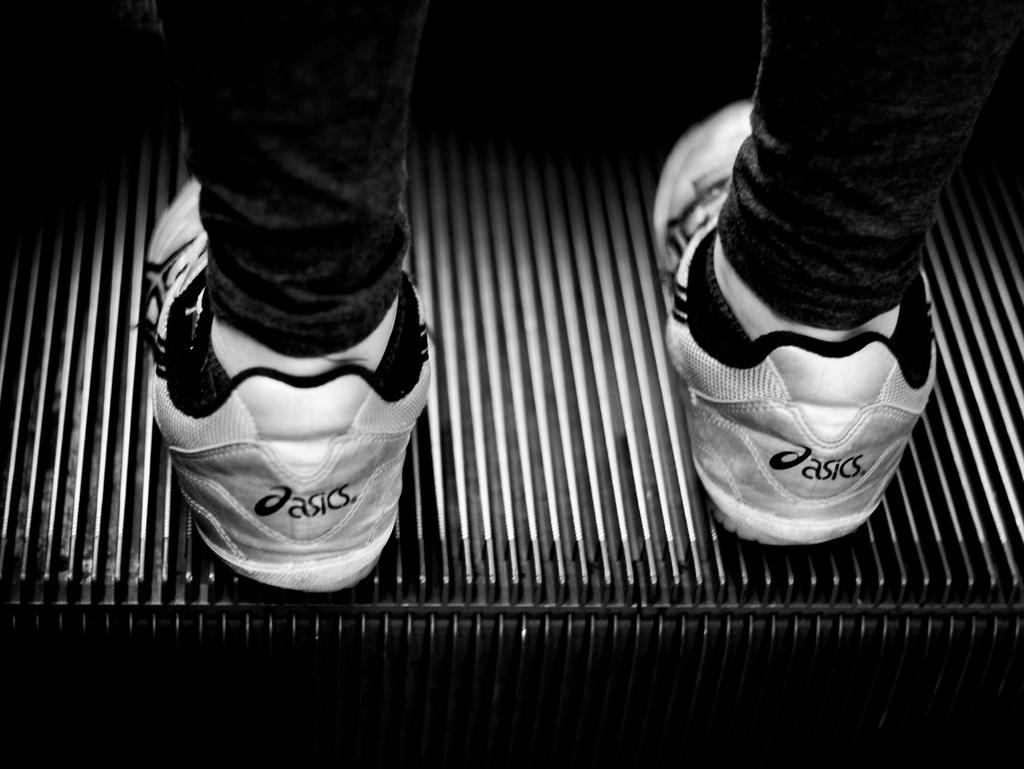What is the main subject in the foreground of the image? There is a person in the foreground of the image. What is the person doing in the image? The person is standing in the image. What type of footwear is the person wearing? The person is wearing shoes. Where is the person standing in the image? The person is standing on an escalator. What type of engine can be seen in the image? There is no engine present in the image. How does the person start the escalator in the image? The person does not start the escalator in the image; they are simply standing on it. 